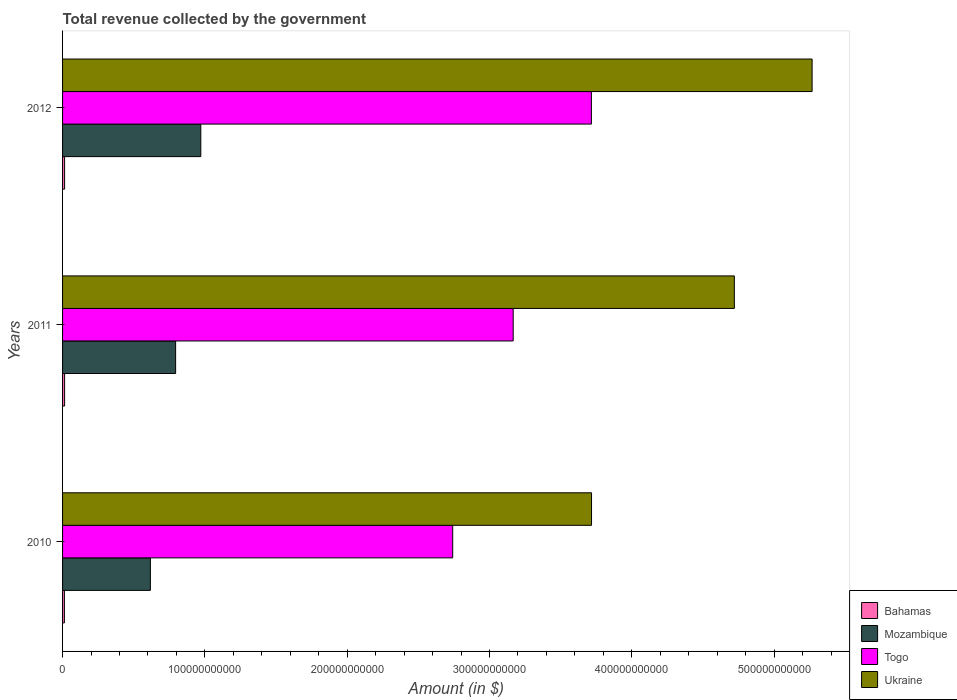How many bars are there on the 2nd tick from the top?
Provide a short and direct response. 4. What is the label of the 2nd group of bars from the top?
Offer a very short reply. 2011. In how many cases, is the number of bars for a given year not equal to the number of legend labels?
Your answer should be very brief. 0. What is the total revenue collected by the government in Ukraine in 2010?
Keep it short and to the point. 3.72e+11. Across all years, what is the maximum total revenue collected by the government in Bahamas?
Your response must be concise. 1.43e+09. Across all years, what is the minimum total revenue collected by the government in Ukraine?
Make the answer very short. 3.72e+11. What is the total total revenue collected by the government in Mozambique in the graph?
Provide a short and direct response. 2.38e+11. What is the difference between the total revenue collected by the government in Togo in 2010 and that in 2012?
Your answer should be compact. -9.74e+1. What is the difference between the total revenue collected by the government in Ukraine in 2010 and the total revenue collected by the government in Togo in 2012?
Your answer should be very brief. 1.01e+08. What is the average total revenue collected by the government in Togo per year?
Your answer should be very brief. 3.21e+11. In the year 2012, what is the difference between the total revenue collected by the government in Ukraine and total revenue collected by the government in Mozambique?
Ensure brevity in your answer.  4.30e+11. What is the ratio of the total revenue collected by the government in Mozambique in 2011 to that in 2012?
Keep it short and to the point. 0.82. Is the difference between the total revenue collected by the government in Ukraine in 2011 and 2012 greater than the difference between the total revenue collected by the government in Mozambique in 2011 and 2012?
Provide a succinct answer. No. What is the difference between the highest and the second highest total revenue collected by the government in Togo?
Provide a succinct answer. 5.49e+1. What is the difference between the highest and the lowest total revenue collected by the government in Bahamas?
Keep it short and to the point. 1.41e+08. Is the sum of the total revenue collected by the government in Ukraine in 2010 and 2012 greater than the maximum total revenue collected by the government in Mozambique across all years?
Make the answer very short. Yes. What does the 3rd bar from the top in 2012 represents?
Your response must be concise. Mozambique. What does the 4th bar from the bottom in 2010 represents?
Your response must be concise. Ukraine. How many bars are there?
Provide a succinct answer. 12. Are all the bars in the graph horizontal?
Your answer should be very brief. Yes. What is the difference between two consecutive major ticks on the X-axis?
Give a very brief answer. 1.00e+11. Are the values on the major ticks of X-axis written in scientific E-notation?
Make the answer very short. No. How many legend labels are there?
Provide a short and direct response. 4. How are the legend labels stacked?
Ensure brevity in your answer.  Vertical. What is the title of the graph?
Provide a succinct answer. Total revenue collected by the government. Does "West Bank and Gaza" appear as one of the legend labels in the graph?
Ensure brevity in your answer.  No. What is the label or title of the X-axis?
Offer a very short reply. Amount (in $). What is the label or title of the Y-axis?
Your response must be concise. Years. What is the Amount (in $) in Bahamas in 2010?
Offer a terse response. 1.29e+09. What is the Amount (in $) in Mozambique in 2010?
Offer a terse response. 6.17e+1. What is the Amount (in $) in Togo in 2010?
Make the answer very short. 2.74e+11. What is the Amount (in $) of Ukraine in 2010?
Ensure brevity in your answer.  3.72e+11. What is the Amount (in $) in Bahamas in 2011?
Keep it short and to the point. 1.43e+09. What is the Amount (in $) in Mozambique in 2011?
Your response must be concise. 7.94e+1. What is the Amount (in $) in Togo in 2011?
Keep it short and to the point. 3.17e+11. What is the Amount (in $) of Ukraine in 2011?
Ensure brevity in your answer.  4.72e+11. What is the Amount (in $) in Bahamas in 2012?
Keep it short and to the point. 1.43e+09. What is the Amount (in $) of Mozambique in 2012?
Provide a short and direct response. 9.71e+1. What is the Amount (in $) in Togo in 2012?
Provide a succinct answer. 3.72e+11. What is the Amount (in $) of Ukraine in 2012?
Make the answer very short. 5.27e+11. Across all years, what is the maximum Amount (in $) in Bahamas?
Give a very brief answer. 1.43e+09. Across all years, what is the maximum Amount (in $) of Mozambique?
Provide a succinct answer. 9.71e+1. Across all years, what is the maximum Amount (in $) of Togo?
Make the answer very short. 3.72e+11. Across all years, what is the maximum Amount (in $) in Ukraine?
Provide a succinct answer. 5.27e+11. Across all years, what is the minimum Amount (in $) in Bahamas?
Keep it short and to the point. 1.29e+09. Across all years, what is the minimum Amount (in $) in Mozambique?
Offer a terse response. 6.17e+1. Across all years, what is the minimum Amount (in $) of Togo?
Provide a short and direct response. 2.74e+11. Across all years, what is the minimum Amount (in $) of Ukraine?
Provide a short and direct response. 3.72e+11. What is the total Amount (in $) in Bahamas in the graph?
Your answer should be compact. 4.15e+09. What is the total Amount (in $) of Mozambique in the graph?
Give a very brief answer. 2.38e+11. What is the total Amount (in $) of Togo in the graph?
Your response must be concise. 9.62e+11. What is the total Amount (in $) of Ukraine in the graph?
Offer a very short reply. 1.37e+12. What is the difference between the Amount (in $) in Bahamas in 2010 and that in 2011?
Give a very brief answer. -1.41e+08. What is the difference between the Amount (in $) in Mozambique in 2010 and that in 2011?
Offer a terse response. -1.77e+1. What is the difference between the Amount (in $) of Togo in 2010 and that in 2011?
Provide a short and direct response. -4.25e+1. What is the difference between the Amount (in $) of Ukraine in 2010 and that in 2011?
Make the answer very short. -1.00e+11. What is the difference between the Amount (in $) in Bahamas in 2010 and that in 2012?
Give a very brief answer. -1.35e+08. What is the difference between the Amount (in $) in Mozambique in 2010 and that in 2012?
Keep it short and to the point. -3.54e+1. What is the difference between the Amount (in $) in Togo in 2010 and that in 2012?
Your answer should be compact. -9.74e+1. What is the difference between the Amount (in $) in Ukraine in 2010 and that in 2012?
Offer a very short reply. -1.55e+11. What is the difference between the Amount (in $) in Bahamas in 2011 and that in 2012?
Ensure brevity in your answer.  6.14e+06. What is the difference between the Amount (in $) of Mozambique in 2011 and that in 2012?
Provide a short and direct response. -1.77e+1. What is the difference between the Amount (in $) in Togo in 2011 and that in 2012?
Provide a succinct answer. -5.49e+1. What is the difference between the Amount (in $) of Ukraine in 2011 and that in 2012?
Offer a very short reply. -5.46e+1. What is the difference between the Amount (in $) in Bahamas in 2010 and the Amount (in $) in Mozambique in 2011?
Provide a succinct answer. -7.81e+1. What is the difference between the Amount (in $) in Bahamas in 2010 and the Amount (in $) in Togo in 2011?
Ensure brevity in your answer.  -3.15e+11. What is the difference between the Amount (in $) of Bahamas in 2010 and the Amount (in $) of Ukraine in 2011?
Offer a terse response. -4.71e+11. What is the difference between the Amount (in $) of Mozambique in 2010 and the Amount (in $) of Togo in 2011?
Give a very brief answer. -2.55e+11. What is the difference between the Amount (in $) in Mozambique in 2010 and the Amount (in $) in Ukraine in 2011?
Provide a short and direct response. -4.10e+11. What is the difference between the Amount (in $) of Togo in 2010 and the Amount (in $) of Ukraine in 2011?
Offer a very short reply. -1.98e+11. What is the difference between the Amount (in $) in Bahamas in 2010 and the Amount (in $) in Mozambique in 2012?
Offer a very short reply. -9.58e+1. What is the difference between the Amount (in $) of Bahamas in 2010 and the Amount (in $) of Togo in 2012?
Provide a succinct answer. -3.70e+11. What is the difference between the Amount (in $) in Bahamas in 2010 and the Amount (in $) in Ukraine in 2012?
Your answer should be compact. -5.25e+11. What is the difference between the Amount (in $) in Mozambique in 2010 and the Amount (in $) in Togo in 2012?
Provide a succinct answer. -3.10e+11. What is the difference between the Amount (in $) in Mozambique in 2010 and the Amount (in $) in Ukraine in 2012?
Give a very brief answer. -4.65e+11. What is the difference between the Amount (in $) in Togo in 2010 and the Amount (in $) in Ukraine in 2012?
Ensure brevity in your answer.  -2.53e+11. What is the difference between the Amount (in $) in Bahamas in 2011 and the Amount (in $) in Mozambique in 2012?
Offer a terse response. -9.57e+1. What is the difference between the Amount (in $) of Bahamas in 2011 and the Amount (in $) of Togo in 2012?
Provide a short and direct response. -3.70e+11. What is the difference between the Amount (in $) in Bahamas in 2011 and the Amount (in $) in Ukraine in 2012?
Ensure brevity in your answer.  -5.25e+11. What is the difference between the Amount (in $) in Mozambique in 2011 and the Amount (in $) in Togo in 2012?
Provide a succinct answer. -2.92e+11. What is the difference between the Amount (in $) in Mozambique in 2011 and the Amount (in $) in Ukraine in 2012?
Make the answer very short. -4.47e+11. What is the difference between the Amount (in $) in Togo in 2011 and the Amount (in $) in Ukraine in 2012?
Make the answer very short. -2.10e+11. What is the average Amount (in $) of Bahamas per year?
Ensure brevity in your answer.  1.38e+09. What is the average Amount (in $) of Mozambique per year?
Offer a very short reply. 7.94e+1. What is the average Amount (in $) of Togo per year?
Offer a terse response. 3.21e+11. What is the average Amount (in $) in Ukraine per year?
Offer a terse response. 4.57e+11. In the year 2010, what is the difference between the Amount (in $) in Bahamas and Amount (in $) in Mozambique?
Ensure brevity in your answer.  -6.04e+1. In the year 2010, what is the difference between the Amount (in $) in Bahamas and Amount (in $) in Togo?
Your answer should be very brief. -2.73e+11. In the year 2010, what is the difference between the Amount (in $) of Bahamas and Amount (in $) of Ukraine?
Ensure brevity in your answer.  -3.70e+11. In the year 2010, what is the difference between the Amount (in $) of Mozambique and Amount (in $) of Togo?
Offer a terse response. -2.12e+11. In the year 2010, what is the difference between the Amount (in $) in Mozambique and Amount (in $) in Ukraine?
Your answer should be very brief. -3.10e+11. In the year 2010, what is the difference between the Amount (in $) in Togo and Amount (in $) in Ukraine?
Give a very brief answer. -9.75e+1. In the year 2011, what is the difference between the Amount (in $) in Bahamas and Amount (in $) in Mozambique?
Keep it short and to the point. -7.80e+1. In the year 2011, what is the difference between the Amount (in $) in Bahamas and Amount (in $) in Togo?
Your answer should be compact. -3.15e+11. In the year 2011, what is the difference between the Amount (in $) of Bahamas and Amount (in $) of Ukraine?
Your answer should be compact. -4.71e+11. In the year 2011, what is the difference between the Amount (in $) of Mozambique and Amount (in $) of Togo?
Provide a short and direct response. -2.37e+11. In the year 2011, what is the difference between the Amount (in $) in Mozambique and Amount (in $) in Ukraine?
Offer a terse response. -3.93e+11. In the year 2011, what is the difference between the Amount (in $) of Togo and Amount (in $) of Ukraine?
Your answer should be compact. -1.55e+11. In the year 2012, what is the difference between the Amount (in $) of Bahamas and Amount (in $) of Mozambique?
Offer a very short reply. -9.57e+1. In the year 2012, what is the difference between the Amount (in $) of Bahamas and Amount (in $) of Togo?
Provide a succinct answer. -3.70e+11. In the year 2012, what is the difference between the Amount (in $) in Bahamas and Amount (in $) in Ukraine?
Give a very brief answer. -5.25e+11. In the year 2012, what is the difference between the Amount (in $) in Mozambique and Amount (in $) in Togo?
Offer a terse response. -2.74e+11. In the year 2012, what is the difference between the Amount (in $) in Mozambique and Amount (in $) in Ukraine?
Keep it short and to the point. -4.30e+11. In the year 2012, what is the difference between the Amount (in $) in Togo and Amount (in $) in Ukraine?
Offer a very short reply. -1.55e+11. What is the ratio of the Amount (in $) of Bahamas in 2010 to that in 2011?
Give a very brief answer. 0.9. What is the ratio of the Amount (in $) in Mozambique in 2010 to that in 2011?
Your answer should be very brief. 0.78. What is the ratio of the Amount (in $) of Togo in 2010 to that in 2011?
Provide a short and direct response. 0.87. What is the ratio of the Amount (in $) of Ukraine in 2010 to that in 2011?
Give a very brief answer. 0.79. What is the ratio of the Amount (in $) in Bahamas in 2010 to that in 2012?
Offer a very short reply. 0.91. What is the ratio of the Amount (in $) of Mozambique in 2010 to that in 2012?
Provide a short and direct response. 0.64. What is the ratio of the Amount (in $) in Togo in 2010 to that in 2012?
Ensure brevity in your answer.  0.74. What is the ratio of the Amount (in $) in Ukraine in 2010 to that in 2012?
Provide a short and direct response. 0.71. What is the ratio of the Amount (in $) of Bahamas in 2011 to that in 2012?
Provide a succinct answer. 1. What is the ratio of the Amount (in $) of Mozambique in 2011 to that in 2012?
Make the answer very short. 0.82. What is the ratio of the Amount (in $) in Togo in 2011 to that in 2012?
Provide a succinct answer. 0.85. What is the ratio of the Amount (in $) of Ukraine in 2011 to that in 2012?
Ensure brevity in your answer.  0.9. What is the difference between the highest and the second highest Amount (in $) of Bahamas?
Your answer should be very brief. 6.14e+06. What is the difference between the highest and the second highest Amount (in $) in Mozambique?
Give a very brief answer. 1.77e+1. What is the difference between the highest and the second highest Amount (in $) in Togo?
Your answer should be very brief. 5.49e+1. What is the difference between the highest and the second highest Amount (in $) in Ukraine?
Your answer should be very brief. 5.46e+1. What is the difference between the highest and the lowest Amount (in $) of Bahamas?
Provide a succinct answer. 1.41e+08. What is the difference between the highest and the lowest Amount (in $) of Mozambique?
Your answer should be compact. 3.54e+1. What is the difference between the highest and the lowest Amount (in $) of Togo?
Keep it short and to the point. 9.74e+1. What is the difference between the highest and the lowest Amount (in $) in Ukraine?
Your response must be concise. 1.55e+11. 